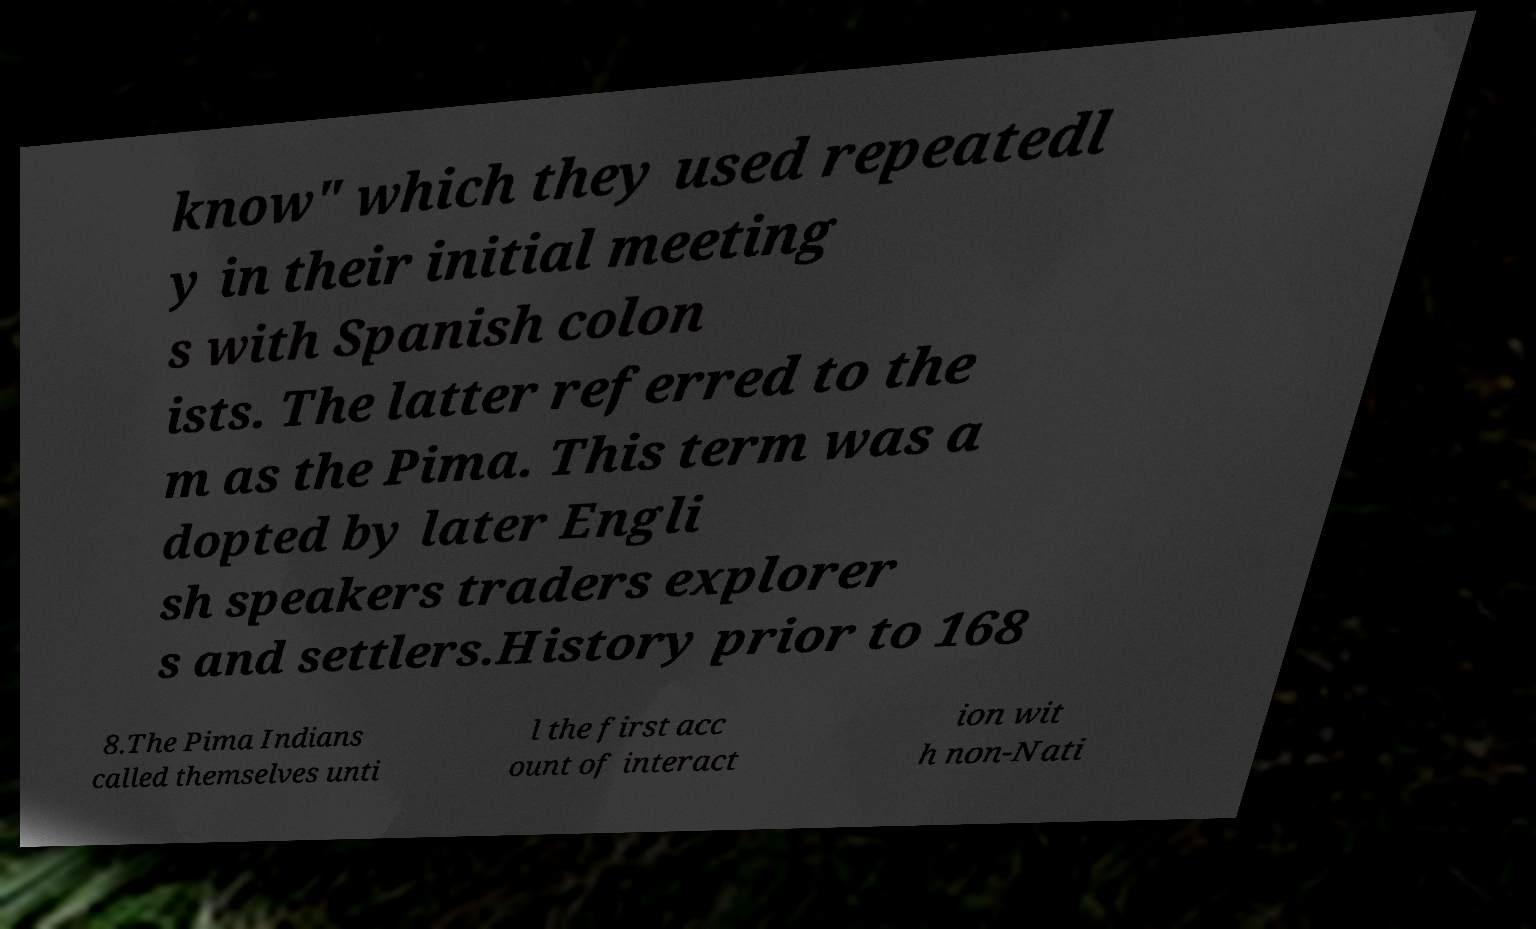I need the written content from this picture converted into text. Can you do that? know" which they used repeatedl y in their initial meeting s with Spanish colon ists. The latter referred to the m as the Pima. This term was a dopted by later Engli sh speakers traders explorer s and settlers.History prior to 168 8.The Pima Indians called themselves unti l the first acc ount of interact ion wit h non-Nati 